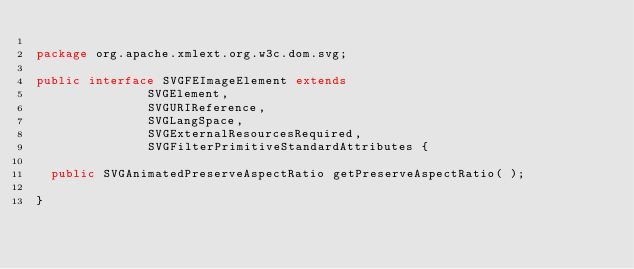<code> <loc_0><loc_0><loc_500><loc_500><_Java_>
package org.apache.xmlext.org.w3c.dom.svg;

public interface SVGFEImageElement extends 
               SVGElement,
               SVGURIReference,
               SVGLangSpace,
               SVGExternalResourcesRequired,
               SVGFilterPrimitiveStandardAttributes {

  public SVGAnimatedPreserveAspectRatio getPreserveAspectRatio( );

}
</code> 